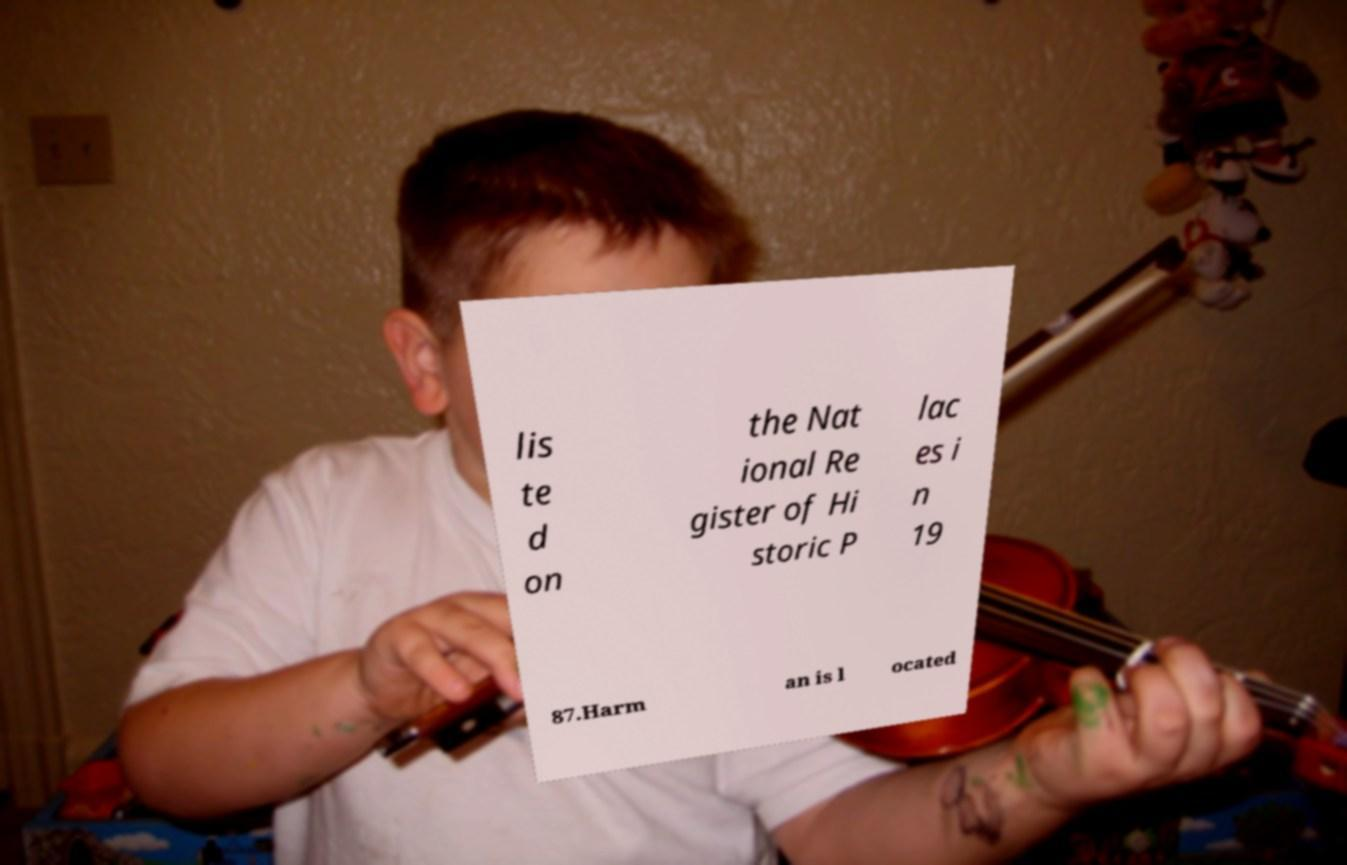Could you extract and type out the text from this image? lis te d on the Nat ional Re gister of Hi storic P lac es i n 19 87.Harm an is l ocated 